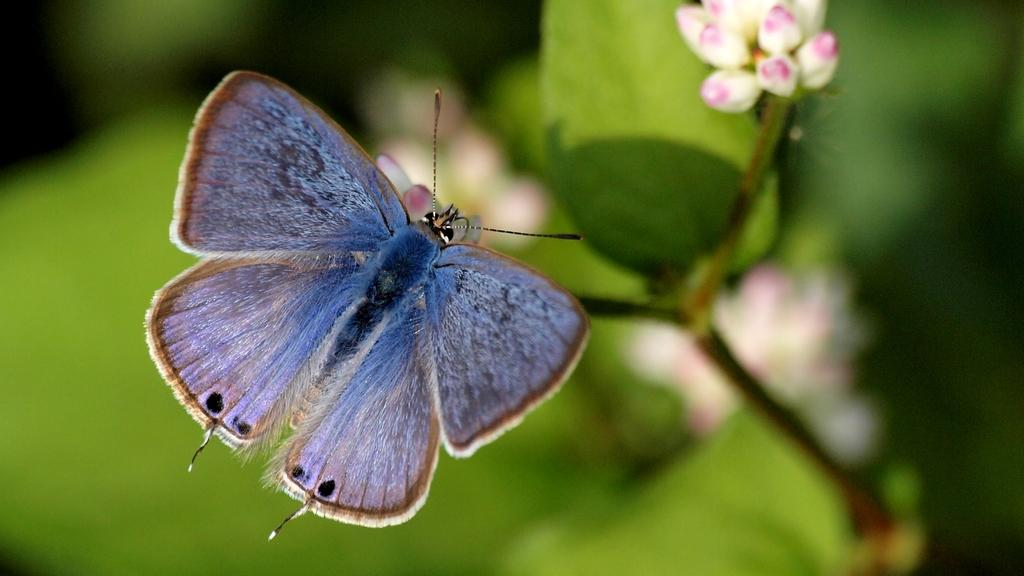What is the main subject of the image? The main subject of the image is a butterfly. Where is the butterfly located in the image? The butterfly is on a plant. What is the color of the background in the image? The background of the image is green in color. What type of soup is being served in the image? There is no soup present in the image; it features a butterfly on a plant. What role does zinc play in the image? There is no mention of zinc in the image, as it features a butterfly on a plant. 